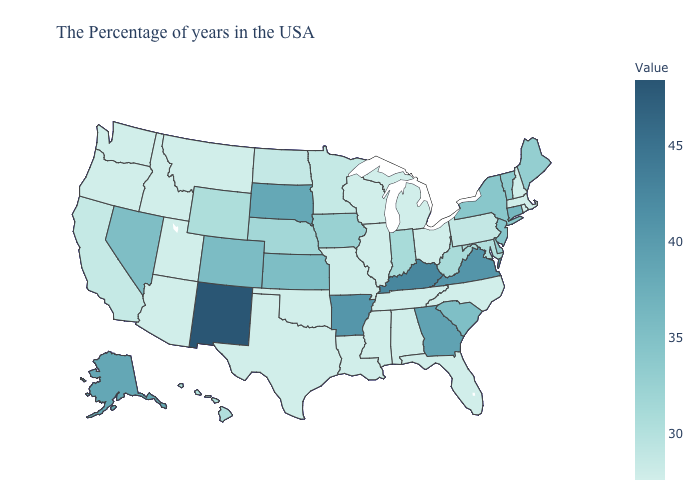Does the map have missing data?
Quick response, please. No. Is the legend a continuous bar?
Write a very short answer. Yes. Does Delaware have a higher value than Kansas?
Give a very brief answer. No. Does Nevada have the lowest value in the West?
Answer briefly. No. Does Utah have the lowest value in the USA?
Answer briefly. Yes. 